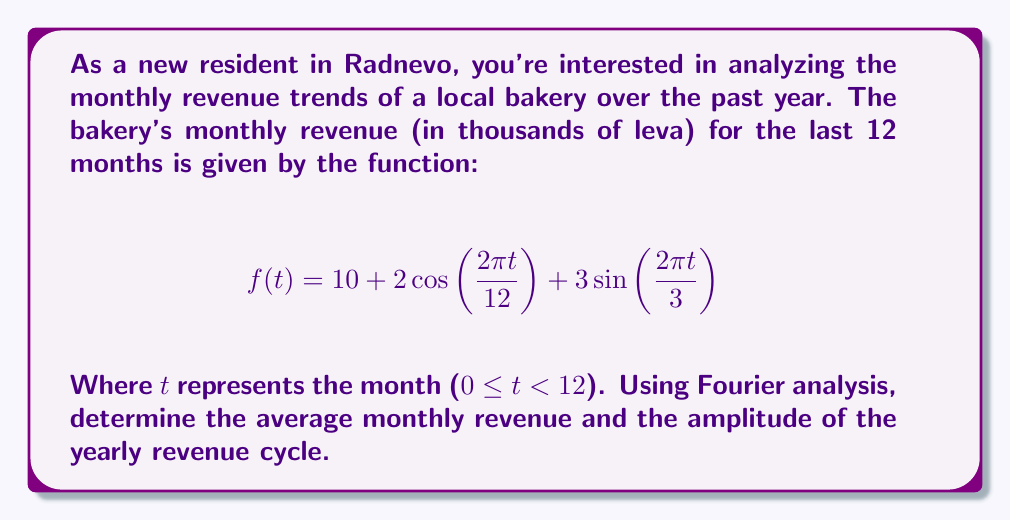Help me with this question. To analyze this revenue function using Fourier analysis, we need to identify the components of the Fourier series representation:

1. The constant term $a_0$ represents the average value of the function over the period.
2. The coefficients of the cosine and sine terms represent the amplitudes of various frequency components.

In this case, we have:

$$f(t) = 10 + 2\cos\left(\frac{2\pi t}{12}\right) + 3\sin\left(\frac{2\pi t}{3}\right)$$

1. Average monthly revenue:
   The constant term $a_0 = 10$ represents the average monthly revenue in thousands of leva.

2. Yearly revenue cycle:
   The term $2\cos\left(\frac{2\pi t}{12}\right)$ represents the yearly cycle because its period is 12 months.
   The amplitude of this cycle is 2 thousand leva.

3. Quarterly revenue cycle:
   The term $3\sin\left(\frac{2\pi t}{3}\right)$ represents a quarterly cycle (period of 3 months).
   This is not part of the question but is worth noting.

Therefore, the average monthly revenue is 10,000 leva, and the amplitude of the yearly revenue cycle is 2,000 leva.
Answer: Average monthly revenue: 10,000 leva
Amplitude of yearly revenue cycle: 2,000 leva 